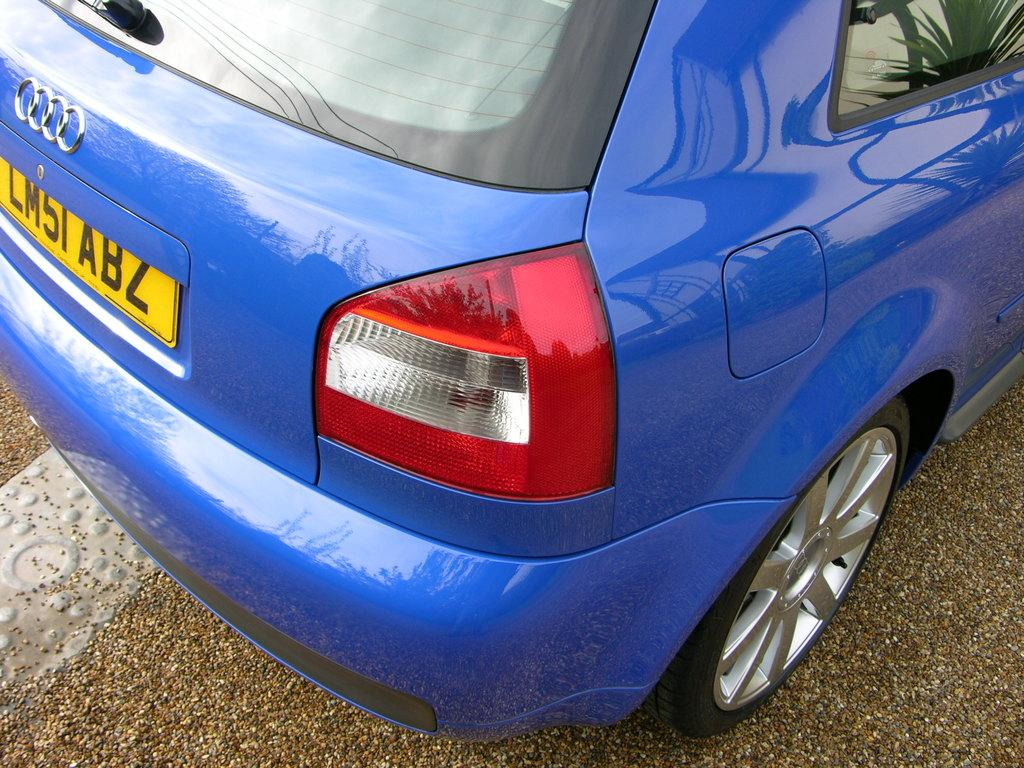What is the main subject of the image? The main subject of the image is a car. Can you describe the car's appearance? The car is blue. Where is the car located in the image? The car is in the center of the image. What is visible at the bottom of the image? There is a road at the bottom of the image. How much rice is being cooked in the car's trunk in the image? There is no rice or cooking activity present in the image; it features a blue car in the center of the image with a road at the bottom. 